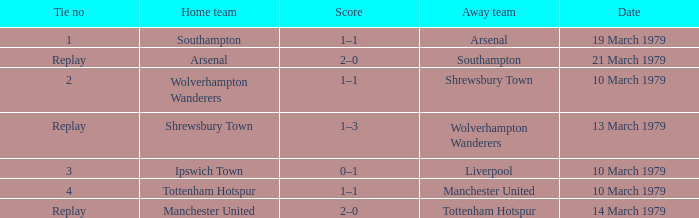Parse the table in full. {'header': ['Tie no', 'Home team', 'Score', 'Away team', 'Date'], 'rows': [['1', 'Southampton', '1–1', 'Arsenal', '19 March 1979'], ['Replay', 'Arsenal', '2–0', 'Southampton', '21 March 1979'], ['2', 'Wolverhampton Wanderers', '1–1', 'Shrewsbury Town', '10 March 1979'], ['Replay', 'Shrewsbury Town', '1–3', 'Wolverhampton Wanderers', '13 March 1979'], ['3', 'Ipswich Town', '0–1', 'Liverpool', '10 March 1979'], ['4', 'Tottenham Hotspur', '1–1', 'Manchester United', '10 March 1979'], ['Replay', 'Manchester United', '2–0', 'Tottenham Hotspur', '14 March 1979']]} In which tie number did arsenal play as the away team? 1.0. 